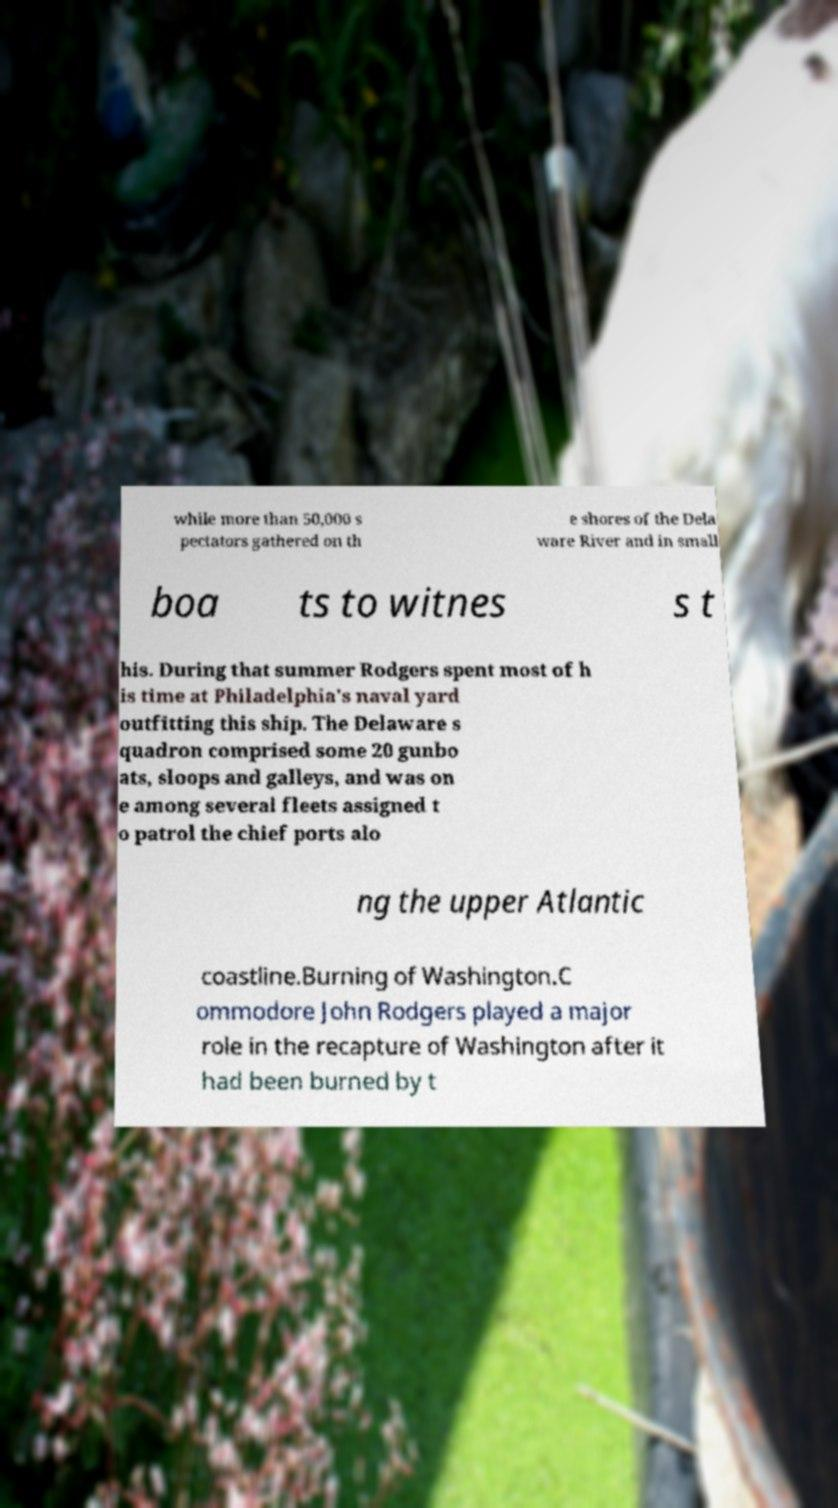There's text embedded in this image that I need extracted. Can you transcribe it verbatim? while more than 50,000 s pectators gathered on th e shores of the Dela ware River and in small boa ts to witnes s t his. During that summer Rodgers spent most of h is time at Philadelphia's naval yard outfitting this ship. The Delaware s quadron comprised some 20 gunbo ats, sloops and galleys, and was on e among several fleets assigned t o patrol the chief ports alo ng the upper Atlantic coastline.Burning of Washington.C ommodore John Rodgers played a major role in the recapture of Washington after it had been burned by t 